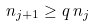Convert formula to latex. <formula><loc_0><loc_0><loc_500><loc_500>n _ { j + 1 } \geq q \, n _ { j }</formula> 